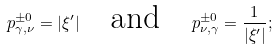<formula> <loc_0><loc_0><loc_500><loc_500>p ^ { \pm 0 } _ { \gamma , \nu } = | \xi ^ { \prime } | \quad \text {and} \quad p ^ { \pm 0 } _ { \nu , \gamma } = \frac { 1 } { | \xi ^ { \prime } | } ;</formula> 